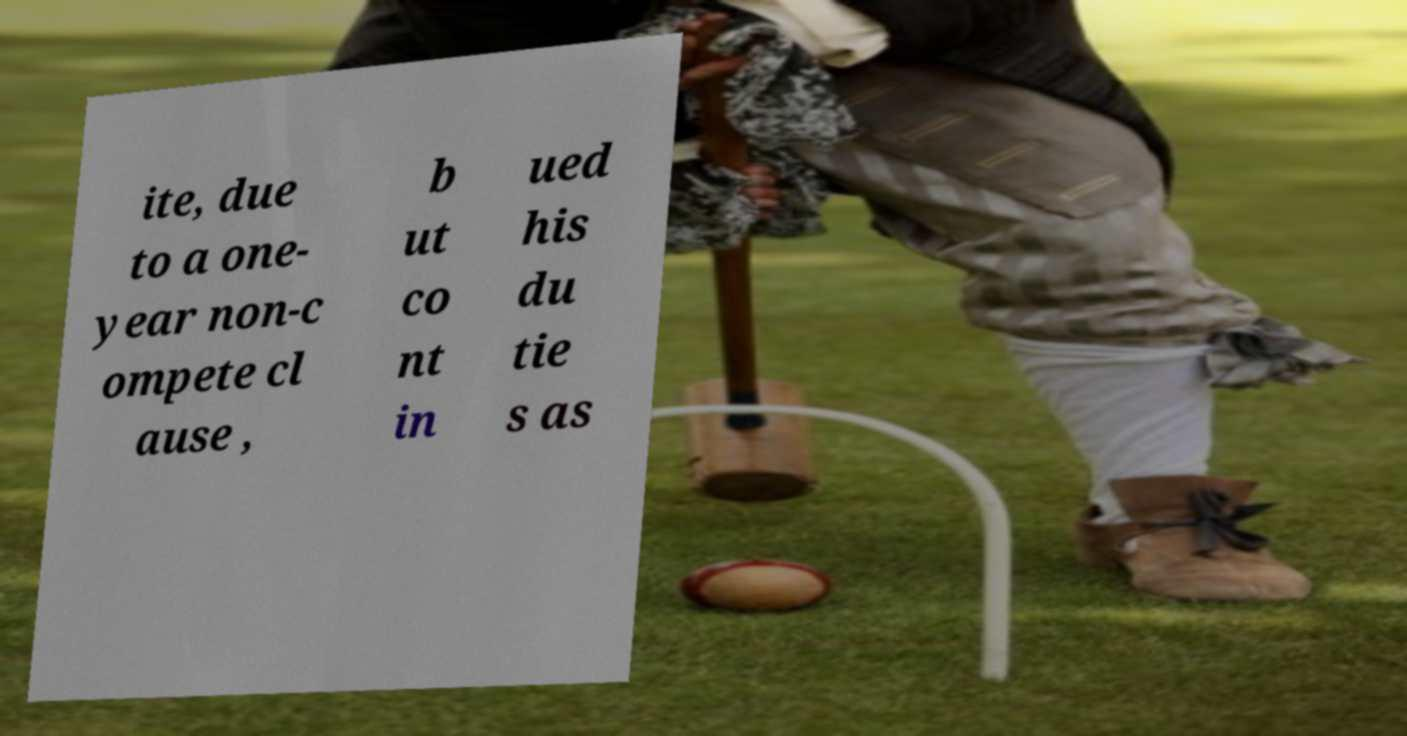I need the written content from this picture converted into text. Can you do that? ite, due to a one- year non-c ompete cl ause , b ut co nt in ued his du tie s as 